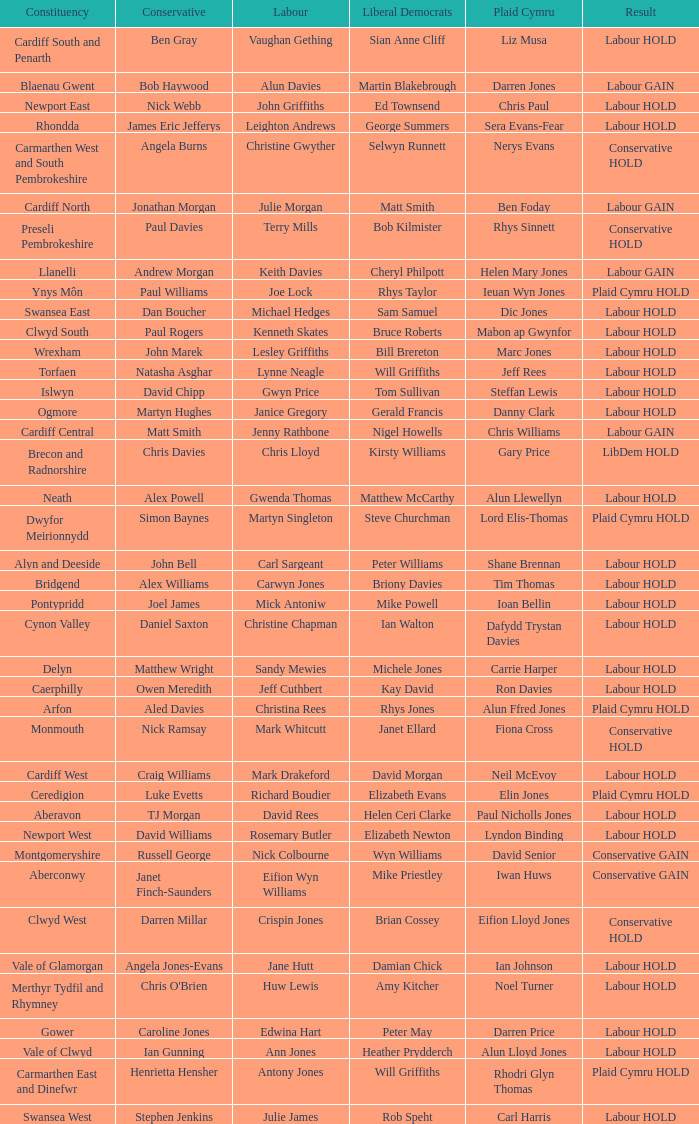Could you parse the entire table as a dict? {'header': ['Constituency', 'Conservative', 'Labour', 'Liberal Democrats', 'Plaid Cymru', 'Result'], 'rows': [['Cardiff South and Penarth', 'Ben Gray', 'Vaughan Gething', 'Sian Anne Cliff', 'Liz Musa', 'Labour HOLD'], ['Blaenau Gwent', 'Bob Haywood', 'Alun Davies', 'Martin Blakebrough', 'Darren Jones', 'Labour GAIN'], ['Newport East', 'Nick Webb', 'John Griffiths', 'Ed Townsend', 'Chris Paul', 'Labour HOLD'], ['Rhondda', 'James Eric Jefferys', 'Leighton Andrews', 'George Summers', 'Sera Evans-Fear', 'Labour HOLD'], ['Carmarthen West and South Pembrokeshire', 'Angela Burns', 'Christine Gwyther', 'Selwyn Runnett', 'Nerys Evans', 'Conservative HOLD'], ['Cardiff North', 'Jonathan Morgan', 'Julie Morgan', 'Matt Smith', 'Ben Foday', 'Labour GAIN'], ['Preseli Pembrokeshire', 'Paul Davies', 'Terry Mills', 'Bob Kilmister', 'Rhys Sinnett', 'Conservative HOLD'], ['Llanelli', 'Andrew Morgan', 'Keith Davies', 'Cheryl Philpott', 'Helen Mary Jones', 'Labour GAIN'], ['Ynys Môn', 'Paul Williams', 'Joe Lock', 'Rhys Taylor', 'Ieuan Wyn Jones', 'Plaid Cymru HOLD'], ['Swansea East', 'Dan Boucher', 'Michael Hedges', 'Sam Samuel', 'Dic Jones', 'Labour HOLD'], ['Clwyd South', 'Paul Rogers', 'Kenneth Skates', 'Bruce Roberts', 'Mabon ap Gwynfor', 'Labour HOLD'], ['Wrexham', 'John Marek', 'Lesley Griffiths', 'Bill Brereton', 'Marc Jones', 'Labour HOLD'], ['Torfaen', 'Natasha Asghar', 'Lynne Neagle', 'Will Griffiths', 'Jeff Rees', 'Labour HOLD'], ['Islwyn', 'David Chipp', 'Gwyn Price', 'Tom Sullivan', 'Steffan Lewis', 'Labour HOLD'], ['Ogmore', 'Martyn Hughes', 'Janice Gregory', 'Gerald Francis', 'Danny Clark', 'Labour HOLD'], ['Cardiff Central', 'Matt Smith', 'Jenny Rathbone', 'Nigel Howells', 'Chris Williams', 'Labour GAIN'], ['Brecon and Radnorshire', 'Chris Davies', 'Chris Lloyd', 'Kirsty Williams', 'Gary Price', 'LibDem HOLD'], ['Neath', 'Alex Powell', 'Gwenda Thomas', 'Matthew McCarthy', 'Alun Llewellyn', 'Labour HOLD'], ['Dwyfor Meirionnydd', 'Simon Baynes', 'Martyn Singleton', 'Steve Churchman', 'Lord Elis-Thomas', 'Plaid Cymru HOLD'], ['Alyn and Deeside', 'John Bell', 'Carl Sargeant', 'Peter Williams', 'Shane Brennan', 'Labour HOLD'], ['Bridgend', 'Alex Williams', 'Carwyn Jones', 'Briony Davies', 'Tim Thomas', 'Labour HOLD'], ['Pontypridd', 'Joel James', 'Mick Antoniw', 'Mike Powell', 'Ioan Bellin', 'Labour HOLD'], ['Cynon Valley', 'Daniel Saxton', 'Christine Chapman', 'Ian Walton', 'Dafydd Trystan Davies', 'Labour HOLD'], ['Delyn', 'Matthew Wright', 'Sandy Mewies', 'Michele Jones', 'Carrie Harper', 'Labour HOLD'], ['Caerphilly', 'Owen Meredith', 'Jeff Cuthbert', 'Kay David', 'Ron Davies', 'Labour HOLD'], ['Arfon', 'Aled Davies', 'Christina Rees', 'Rhys Jones', 'Alun Ffred Jones', 'Plaid Cymru HOLD'], ['Monmouth', 'Nick Ramsay', 'Mark Whitcutt', 'Janet Ellard', 'Fiona Cross', 'Conservative HOLD'], ['Cardiff West', 'Craig Williams', 'Mark Drakeford', 'David Morgan', 'Neil McEvoy', 'Labour HOLD'], ['Ceredigion', 'Luke Evetts', 'Richard Boudier', 'Elizabeth Evans', 'Elin Jones', 'Plaid Cymru HOLD'], ['Aberavon', 'TJ Morgan', 'David Rees', 'Helen Ceri Clarke', 'Paul Nicholls Jones', 'Labour HOLD'], ['Newport West', 'David Williams', 'Rosemary Butler', 'Elizabeth Newton', 'Lyndon Binding', 'Labour HOLD'], ['Montgomeryshire', 'Russell George', 'Nick Colbourne', 'Wyn Williams', 'David Senior', 'Conservative GAIN'], ['Aberconwy', 'Janet Finch-Saunders', 'Eifion Wyn Williams', 'Mike Priestley', 'Iwan Huws', 'Conservative GAIN'], ['Clwyd West', 'Darren Millar', 'Crispin Jones', 'Brian Cossey', 'Eifion Lloyd Jones', 'Conservative HOLD'], ['Vale of Glamorgan', 'Angela Jones-Evans', 'Jane Hutt', 'Damian Chick', 'Ian Johnson', 'Labour HOLD'], ['Merthyr Tydfil and Rhymney', "Chris O'Brien", 'Huw Lewis', 'Amy Kitcher', 'Noel Turner', 'Labour HOLD'], ['Gower', 'Caroline Jones', 'Edwina Hart', 'Peter May', 'Darren Price', 'Labour HOLD'], ['Vale of Clwyd', 'Ian Gunning', 'Ann Jones', 'Heather Prydderch', 'Alun Lloyd Jones', 'Labour HOLD'], ['Carmarthen East and Dinefwr', 'Henrietta Hensher', 'Antony Jones', 'Will Griffiths', 'Rhodri Glyn Thomas', 'Plaid Cymru HOLD'], ['Swansea West', 'Stephen Jenkins', 'Julie James', 'Rob Speht', 'Carl Harris', 'Labour HOLD']]} What constituency does the Conservative Darren Millar belong to? Clwyd West. 